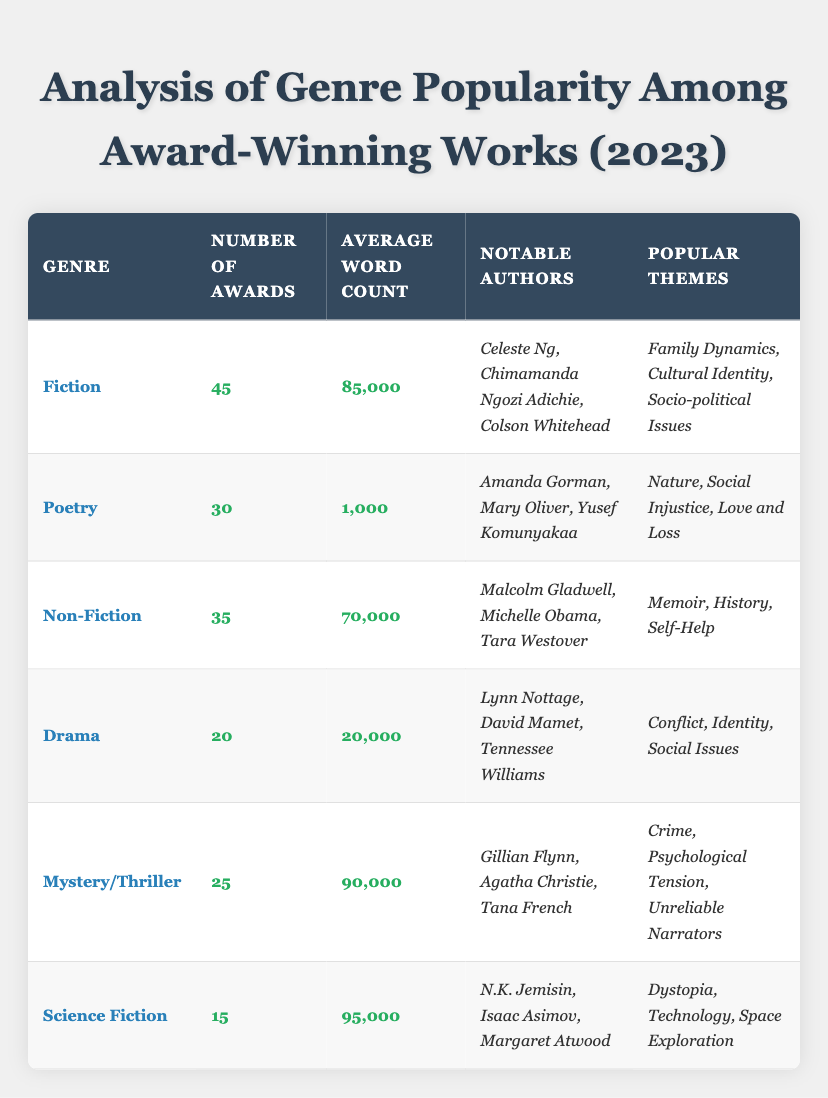What is the genre with the highest number of awards? The genre with the highest number of awards is Fiction, which has received 45 awards, more than any other genre listed.
Answer: Fiction What is the average word count for the Poetry genre? The average word count for Poetry is 1,000 words, as directly stated in the table under that genre.
Answer: 1,000 How many total awards were given across all genres? To find the total number of awards, we sum the awards: 45 (Fiction) + 30 (Poetry) + 35 (Non-Fiction) + 20 (Drama) + 25 (Mystery/Thriller) + 15 (Science Fiction) = 170.
Answer: 170 Is the average word count for Non-Fiction greater than that of Drama? The average word count for Non-Fiction is 70,000, while for Drama, it's 20,000, so Non-Fiction has a greater average word count.
Answer: Yes What is the difference in the number of awards between Mystery/Thriller and Science Fiction? Mystery/Thriller received 25 awards while Science Fiction received 15 awards. The difference is 25 - 15 = 10.
Answer: 10 Identify one popular theme from the Drama genre. One popular theme from the Drama genre is Conflict, as listed in the themes column for that genre.
Answer: Conflict Which genre has the lowest average word count? Science Fiction has the lowest average word count of 95,000, as compared to others listed, confirming that it's the lowest among the entries.
Answer: Science Fiction If we consider the top two genres by awards, what are their average word counts? The top two genres by awards are Fiction (85,000) and Non-Fiction (70,000). Their average is (85,000 + 70,000) / 2 = 77,500.
Answer: 77,500 Which genre has the most notable authors? All genres have a slight variation, but in terms of count, both Fiction and Non-Fiction have three notable authors listed, making them equal.
Answer: Fiction and Non-Fiction Are there more notable authors in Poetry than in Drama? Poetry has three notable authors while Drama also lists three, which means there are not more in Poetry than Drama.
Answer: No 